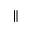<formula> <loc_0><loc_0><loc_500><loc_500>\|</formula> 